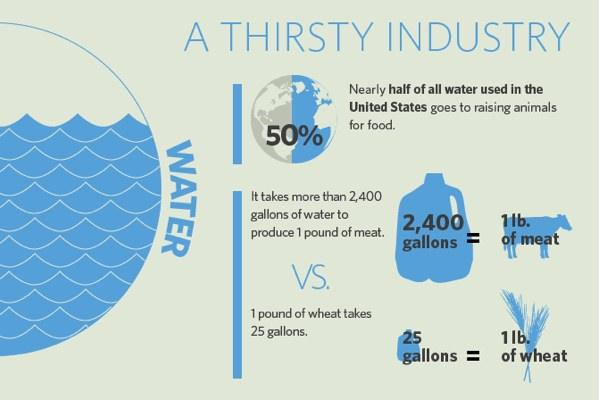Mention a couple of crucial points in this snapshot. There is only one cow depicted in this infographic. 